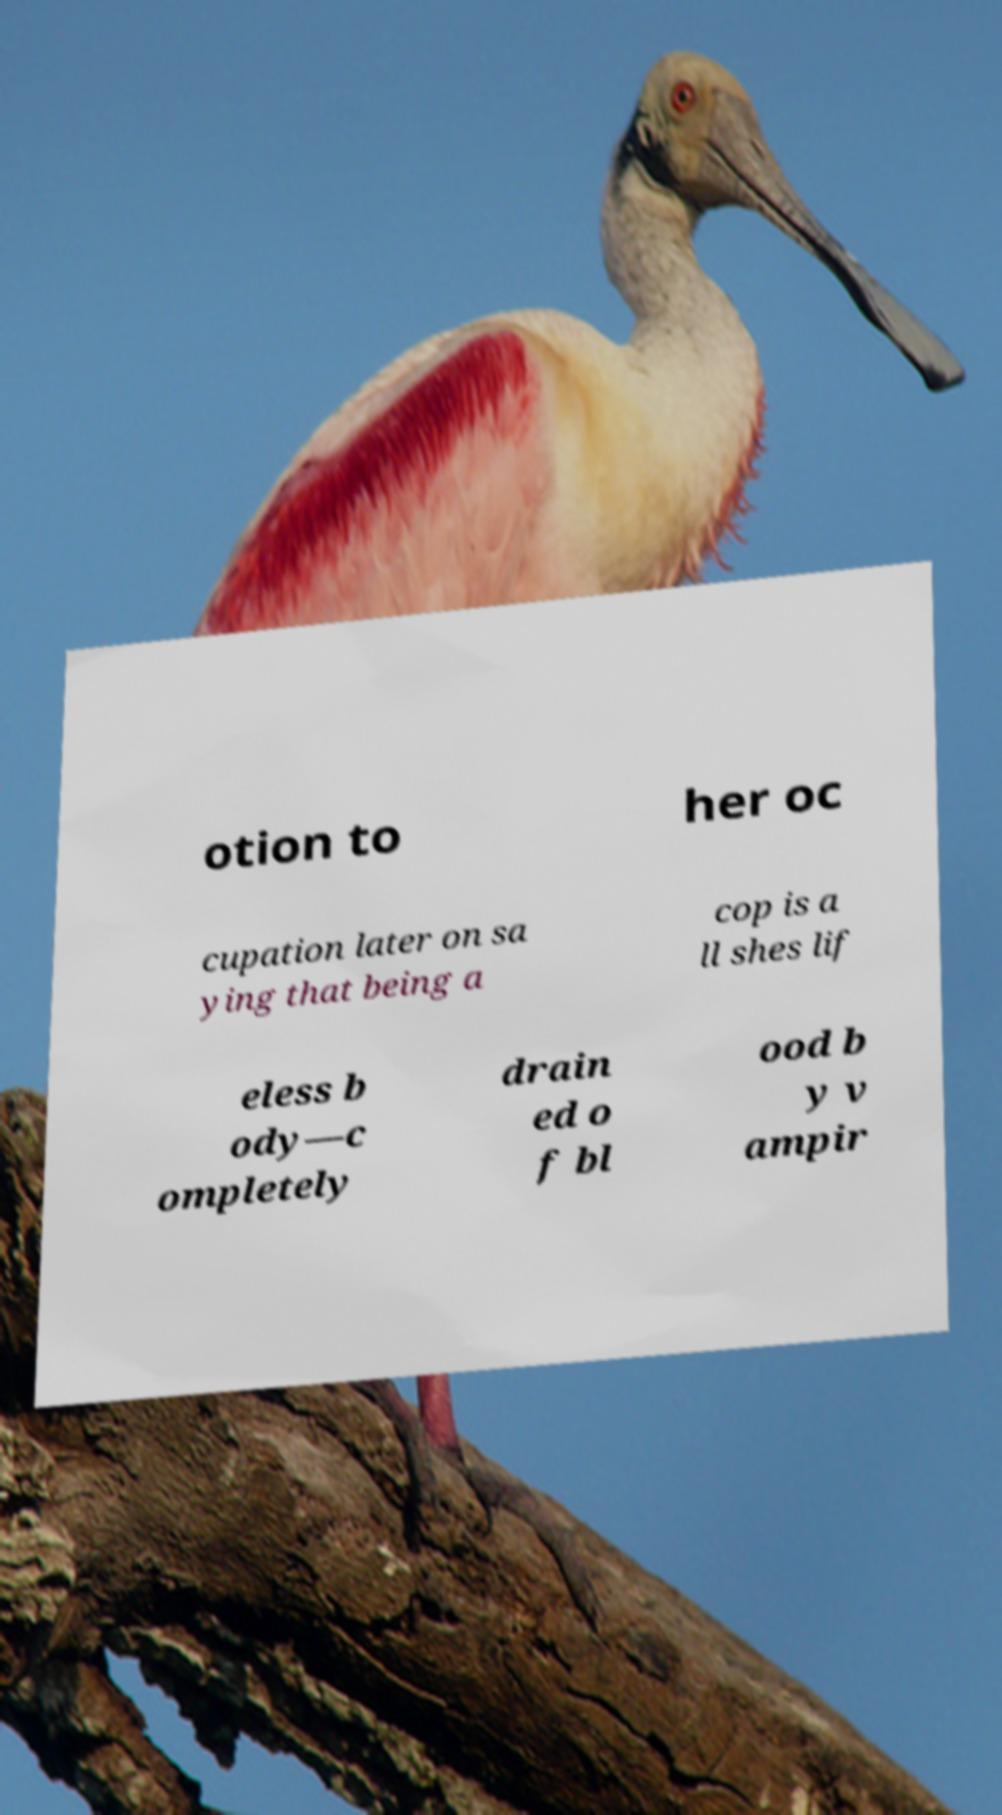I need the written content from this picture converted into text. Can you do that? otion to her oc cupation later on sa ying that being a cop is a ll shes lif eless b ody—c ompletely drain ed o f bl ood b y v ampir 